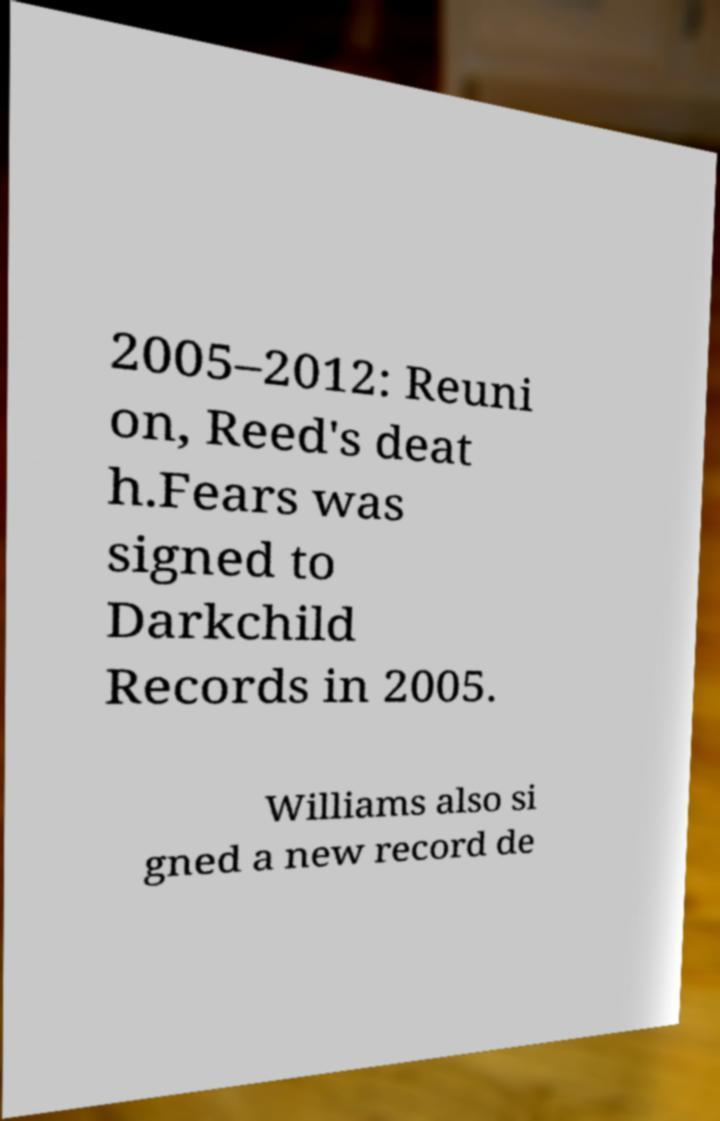What messages or text are displayed in this image? I need them in a readable, typed format. 2005–2012: Reuni on, Reed's deat h.Fears was signed to Darkchild Records in 2005. Williams also si gned a new record de 